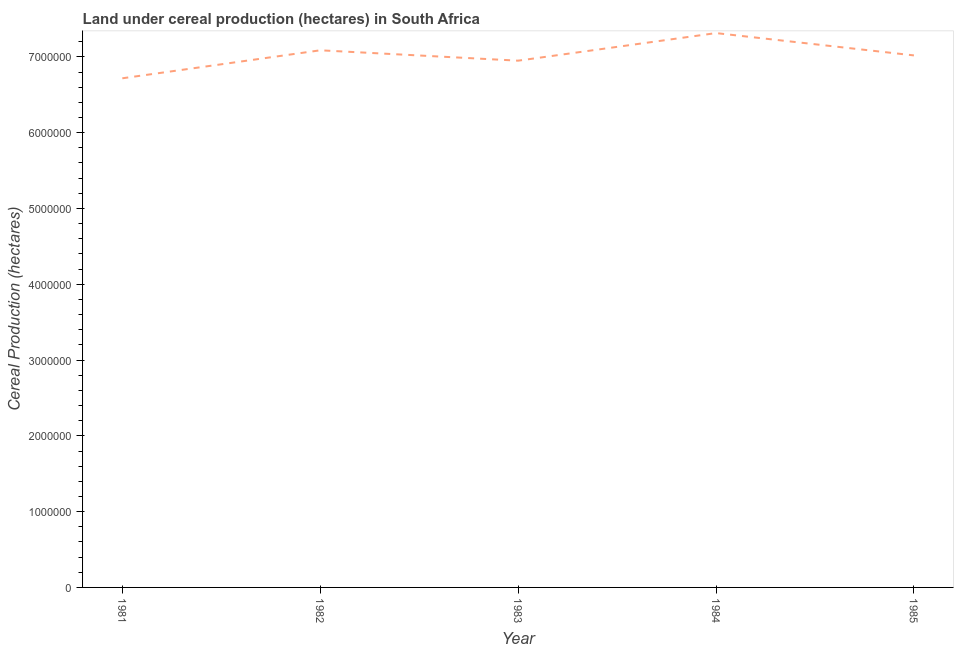What is the land under cereal production in 1984?
Provide a short and direct response. 7.31e+06. Across all years, what is the maximum land under cereal production?
Your answer should be compact. 7.31e+06. Across all years, what is the minimum land under cereal production?
Keep it short and to the point. 6.72e+06. In which year was the land under cereal production maximum?
Offer a very short reply. 1984. What is the sum of the land under cereal production?
Offer a terse response. 3.51e+07. What is the difference between the land under cereal production in 1982 and 1983?
Offer a terse response. 1.37e+05. What is the average land under cereal production per year?
Your answer should be very brief. 7.02e+06. What is the median land under cereal production?
Make the answer very short. 7.02e+06. Do a majority of the years between 1985 and 1984 (inclusive) have land under cereal production greater than 2600000 hectares?
Make the answer very short. No. What is the ratio of the land under cereal production in 1981 to that in 1985?
Your answer should be very brief. 0.96. What is the difference between the highest and the second highest land under cereal production?
Offer a terse response. 2.27e+05. What is the difference between the highest and the lowest land under cereal production?
Your answer should be very brief. 5.96e+05. Does the land under cereal production monotonically increase over the years?
Your answer should be very brief. No. How many lines are there?
Provide a short and direct response. 1. How many years are there in the graph?
Your answer should be very brief. 5. What is the difference between two consecutive major ticks on the Y-axis?
Your response must be concise. 1.00e+06. Are the values on the major ticks of Y-axis written in scientific E-notation?
Give a very brief answer. No. Does the graph contain any zero values?
Your answer should be very brief. No. Does the graph contain grids?
Ensure brevity in your answer.  No. What is the title of the graph?
Provide a succinct answer. Land under cereal production (hectares) in South Africa. What is the label or title of the Y-axis?
Ensure brevity in your answer.  Cereal Production (hectares). What is the Cereal Production (hectares) in 1981?
Your answer should be very brief. 6.72e+06. What is the Cereal Production (hectares) of 1982?
Give a very brief answer. 7.09e+06. What is the Cereal Production (hectares) in 1983?
Your answer should be compact. 6.95e+06. What is the Cereal Production (hectares) in 1984?
Your answer should be very brief. 7.31e+06. What is the Cereal Production (hectares) of 1985?
Your response must be concise. 7.02e+06. What is the difference between the Cereal Production (hectares) in 1981 and 1982?
Provide a short and direct response. -3.70e+05. What is the difference between the Cereal Production (hectares) in 1981 and 1983?
Your response must be concise. -2.32e+05. What is the difference between the Cereal Production (hectares) in 1981 and 1984?
Offer a very short reply. -5.96e+05. What is the difference between the Cereal Production (hectares) in 1981 and 1985?
Provide a succinct answer. -3.02e+05. What is the difference between the Cereal Production (hectares) in 1982 and 1983?
Ensure brevity in your answer.  1.37e+05. What is the difference between the Cereal Production (hectares) in 1982 and 1984?
Ensure brevity in your answer.  -2.27e+05. What is the difference between the Cereal Production (hectares) in 1982 and 1985?
Your answer should be compact. 6.75e+04. What is the difference between the Cereal Production (hectares) in 1983 and 1984?
Ensure brevity in your answer.  -3.64e+05. What is the difference between the Cereal Production (hectares) in 1983 and 1985?
Your answer should be very brief. -6.95e+04. What is the difference between the Cereal Production (hectares) in 1984 and 1985?
Ensure brevity in your answer.  2.94e+05. What is the ratio of the Cereal Production (hectares) in 1981 to that in 1982?
Your response must be concise. 0.95. What is the ratio of the Cereal Production (hectares) in 1981 to that in 1983?
Your answer should be compact. 0.97. What is the ratio of the Cereal Production (hectares) in 1981 to that in 1984?
Provide a short and direct response. 0.92. What is the ratio of the Cereal Production (hectares) in 1982 to that in 1984?
Offer a very short reply. 0.97. What is the ratio of the Cereal Production (hectares) in 1982 to that in 1985?
Your answer should be very brief. 1.01. What is the ratio of the Cereal Production (hectares) in 1984 to that in 1985?
Offer a very short reply. 1.04. 